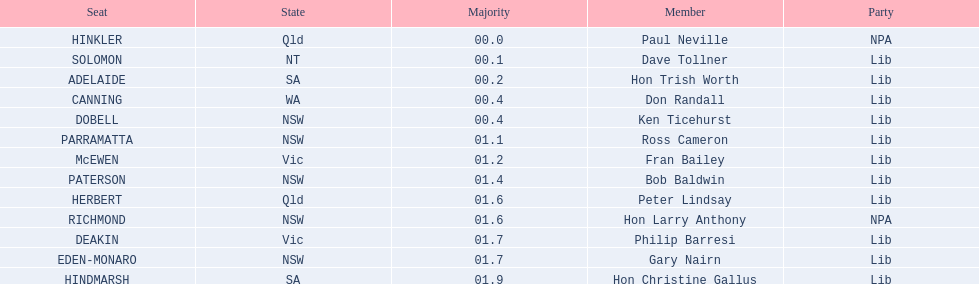In which state can hinkler be found? Qld. What is the primary distinction between south australia and queensland? 01.9. 